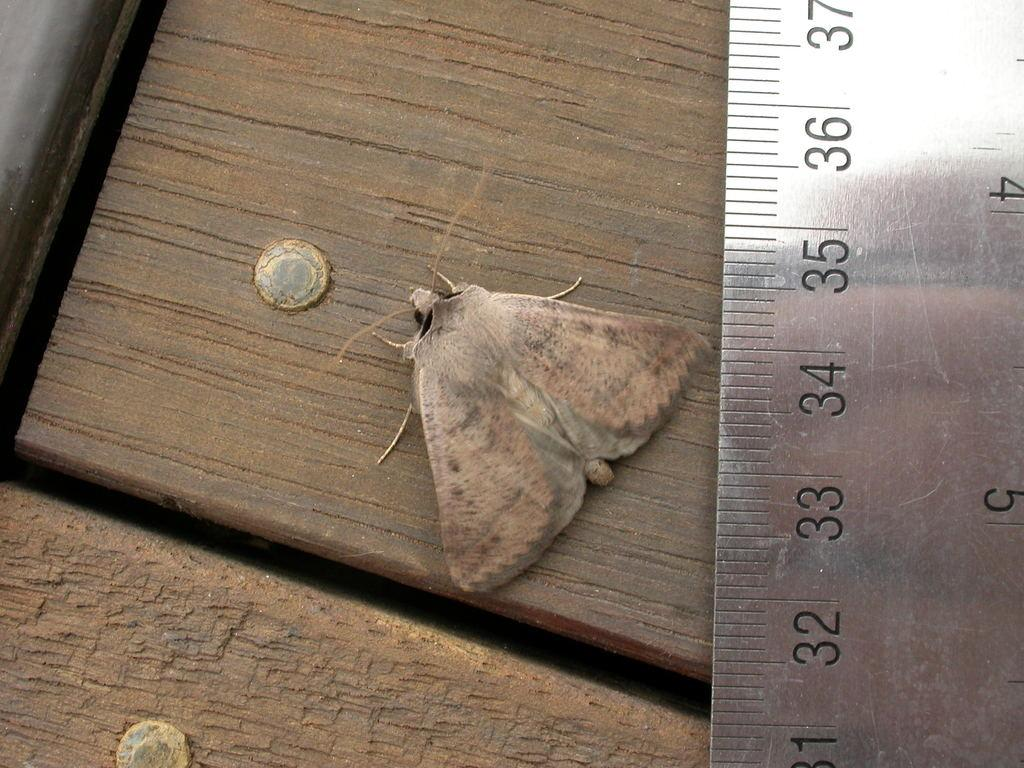Provide a one-sentence caption for the provided image. A silver ruler showing the the moth at approximately the 34 inch mark. 